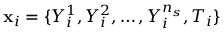<formula> <loc_0><loc_0><loc_500><loc_500>x _ { i } = \{ Y _ { i } ^ { 1 } , Y _ { i } ^ { 2 } , \dots , Y _ { i } ^ { n _ { s } } , T _ { i } \}</formula> 